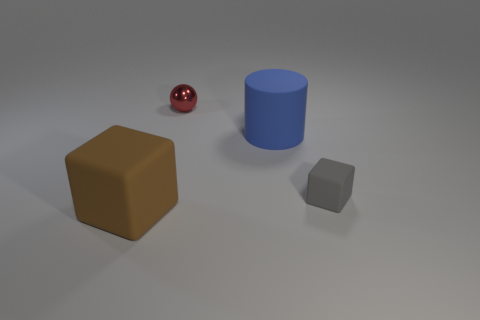Add 4 purple shiny things. How many objects exist? 8 Subtract all cylinders. How many objects are left? 3 Add 2 rubber cylinders. How many rubber cylinders exist? 3 Subtract 0 gray spheres. How many objects are left? 4 Subtract all tiny blocks. Subtract all tiny cyan matte things. How many objects are left? 3 Add 3 matte cylinders. How many matte cylinders are left? 4 